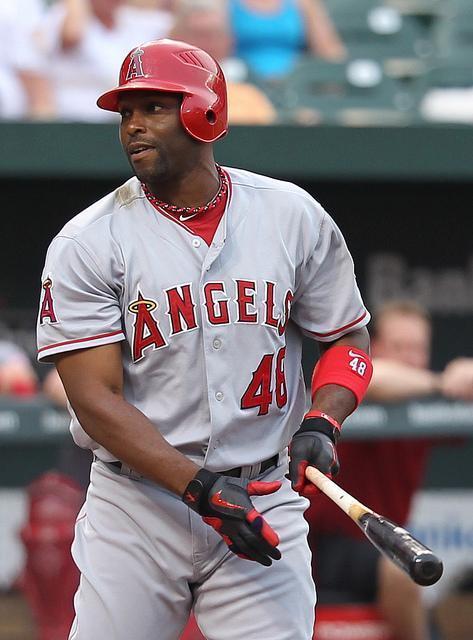How many baseball bats are there?
Give a very brief answer. 1. How many people can be seen?
Give a very brief answer. 2. How many adult birds are there?
Give a very brief answer. 0. 